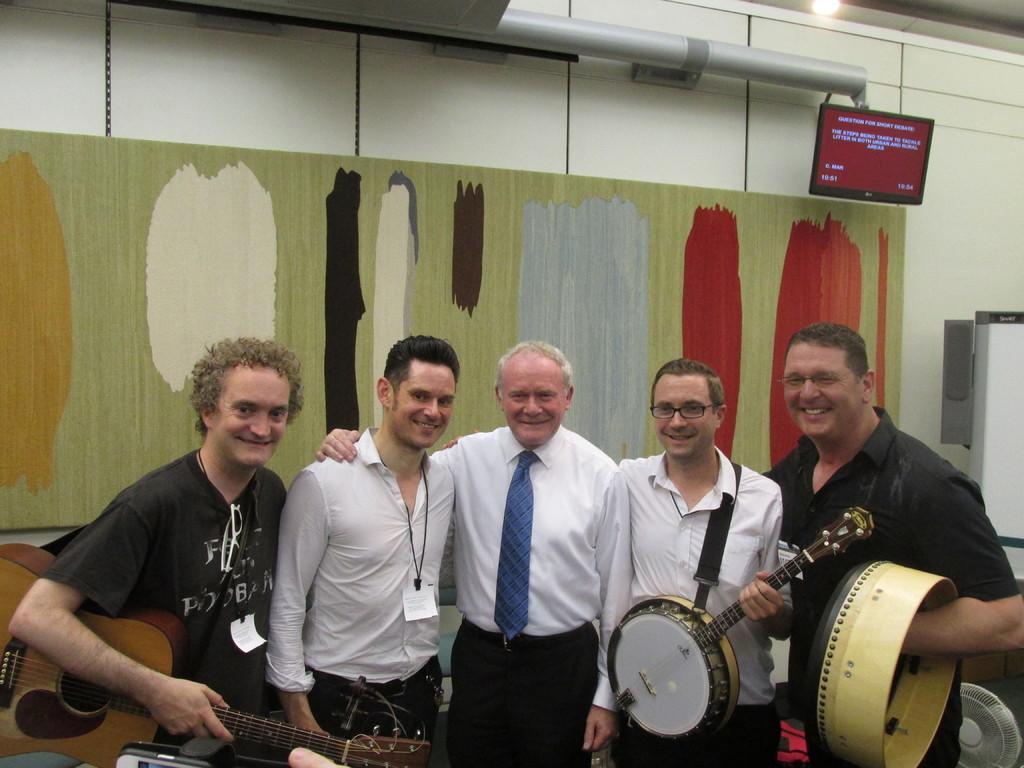Can you describe this image briefly? In this image there are five persons standing. Three persons at the middle are wearing white shirt in which one person is holding a musical instrument. Person at the left side is wearing a black shirt and holding a guitar. The person at the right side is wearing a black shirt and holding another musical instrument. At the right bottom there is a fan. At the right side there is a screen changed to the wall. BAckground there is a canvas attached to the wall. At the top there is a pipe and light. 